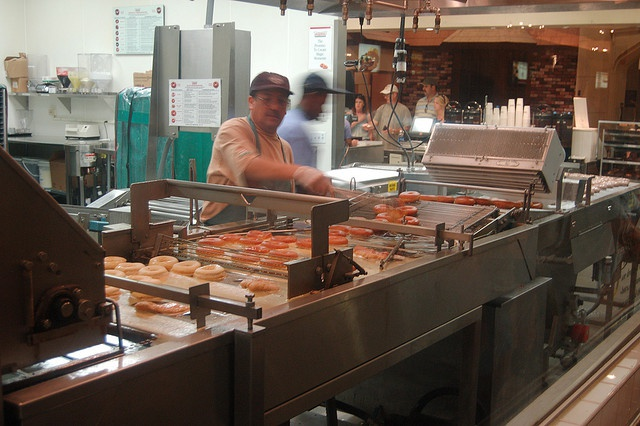Describe the objects in this image and their specific colors. I can see people in lightgray, brown, maroon, and gray tones, donut in lightgray, gray, brown, maroon, and tan tones, people in lightgray, gray, maroon, and darkgray tones, people in lightgray, gray, and darkgray tones, and people in lightgray, gray, maroon, darkgray, and tan tones in this image. 